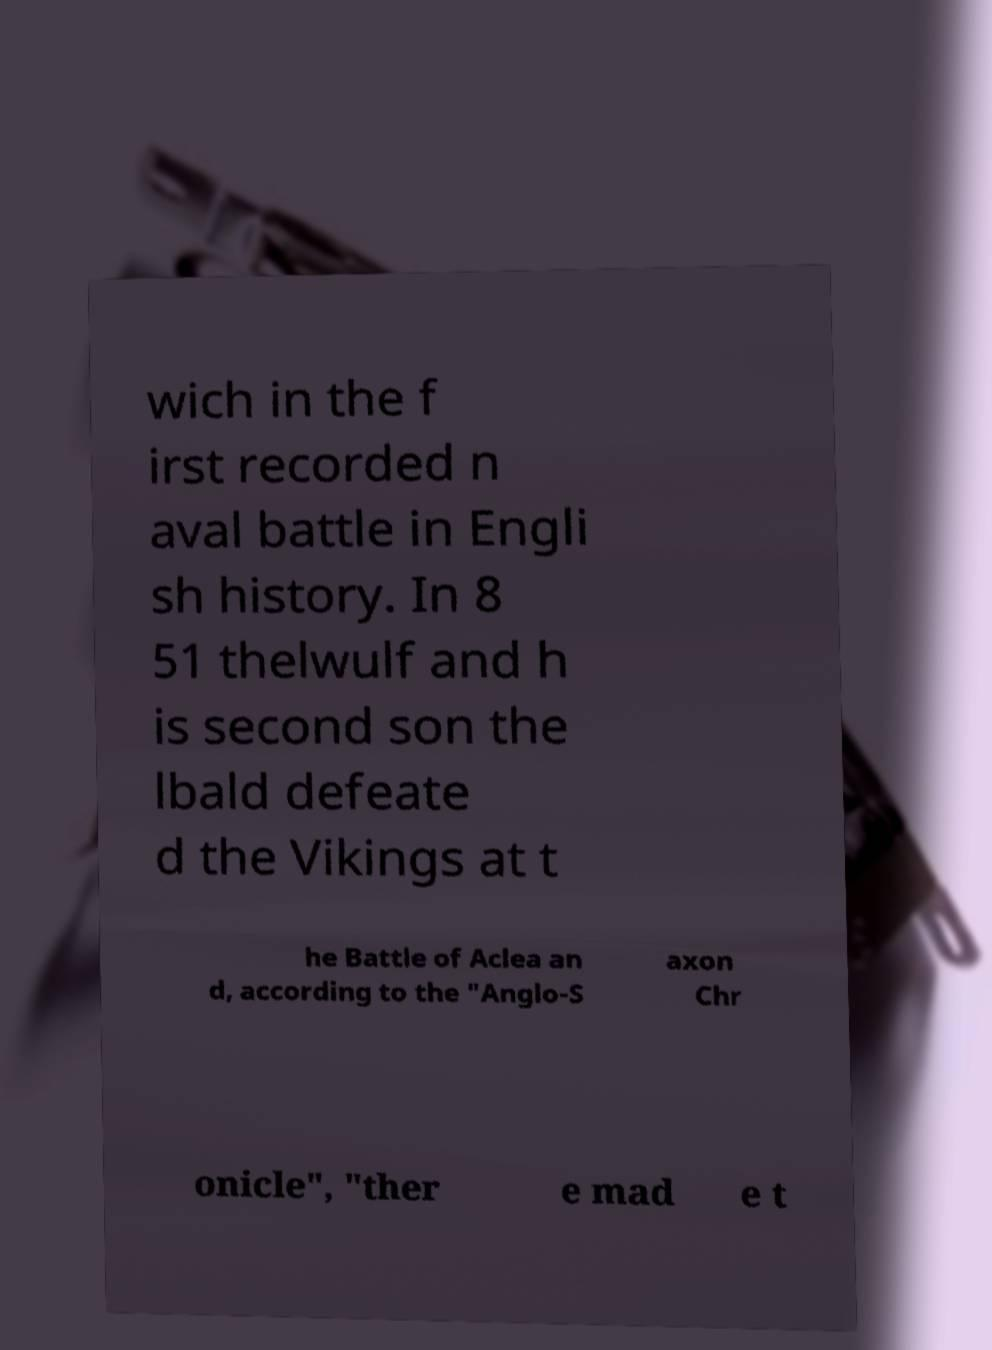Could you extract and type out the text from this image? wich in the f irst recorded n aval battle in Engli sh history. In 8 51 thelwulf and h is second son the lbald defeate d the Vikings at t he Battle of Aclea an d, according to the "Anglo-S axon Chr onicle", "ther e mad e t 